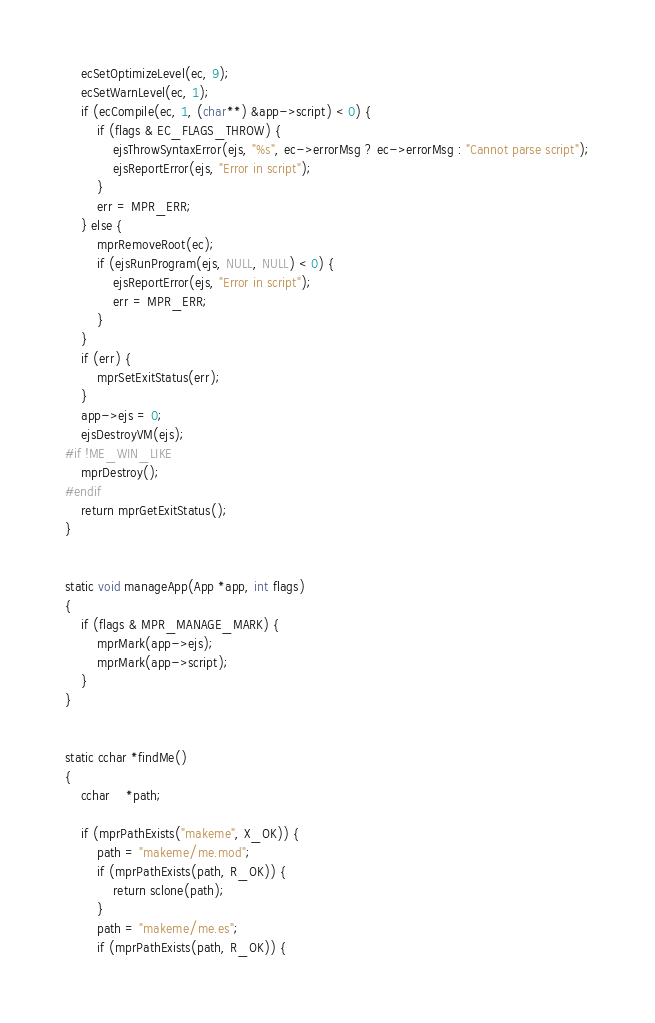<code> <loc_0><loc_0><loc_500><loc_500><_C_>    ecSetOptimizeLevel(ec, 9);
    ecSetWarnLevel(ec, 1);
    if (ecCompile(ec, 1, (char**) &app->script) < 0) {
        if (flags & EC_FLAGS_THROW) {
            ejsThrowSyntaxError(ejs, "%s", ec->errorMsg ? ec->errorMsg : "Cannot parse script");
            ejsReportError(ejs, "Error in script");
        }
        err = MPR_ERR;
    } else {
        mprRemoveRoot(ec);
        if (ejsRunProgram(ejs, NULL, NULL) < 0) {
            ejsReportError(ejs, "Error in script");
            err = MPR_ERR;
        }
    }
    if (err) {
        mprSetExitStatus(err);
    }
    app->ejs = 0;
    ejsDestroyVM(ejs);
#if !ME_WIN_LIKE
    mprDestroy();
#endif
    return mprGetExitStatus();
}


static void manageApp(App *app, int flags)
{
    if (flags & MPR_MANAGE_MARK) {
        mprMark(app->ejs);
        mprMark(app->script);
    }
}


static cchar *findMe()
{
    cchar    *path;

    if (mprPathExists("makeme", X_OK)) {
        path = "makeme/me.mod"; 
        if (mprPathExists(path, R_OK)) {
            return sclone(path);
        }
        path = "makeme/me.es"; 
        if (mprPathExists(path, R_OK)) {</code> 